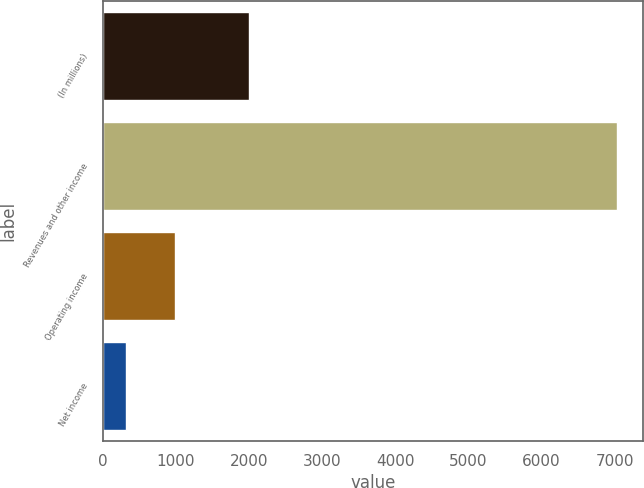<chart> <loc_0><loc_0><loc_500><loc_500><bar_chart><fcel>(In millions)<fcel>Revenues and other income<fcel>Operating income<fcel>Net income<nl><fcel>2003<fcel>7036<fcel>990.7<fcel>319<nl></chart> 